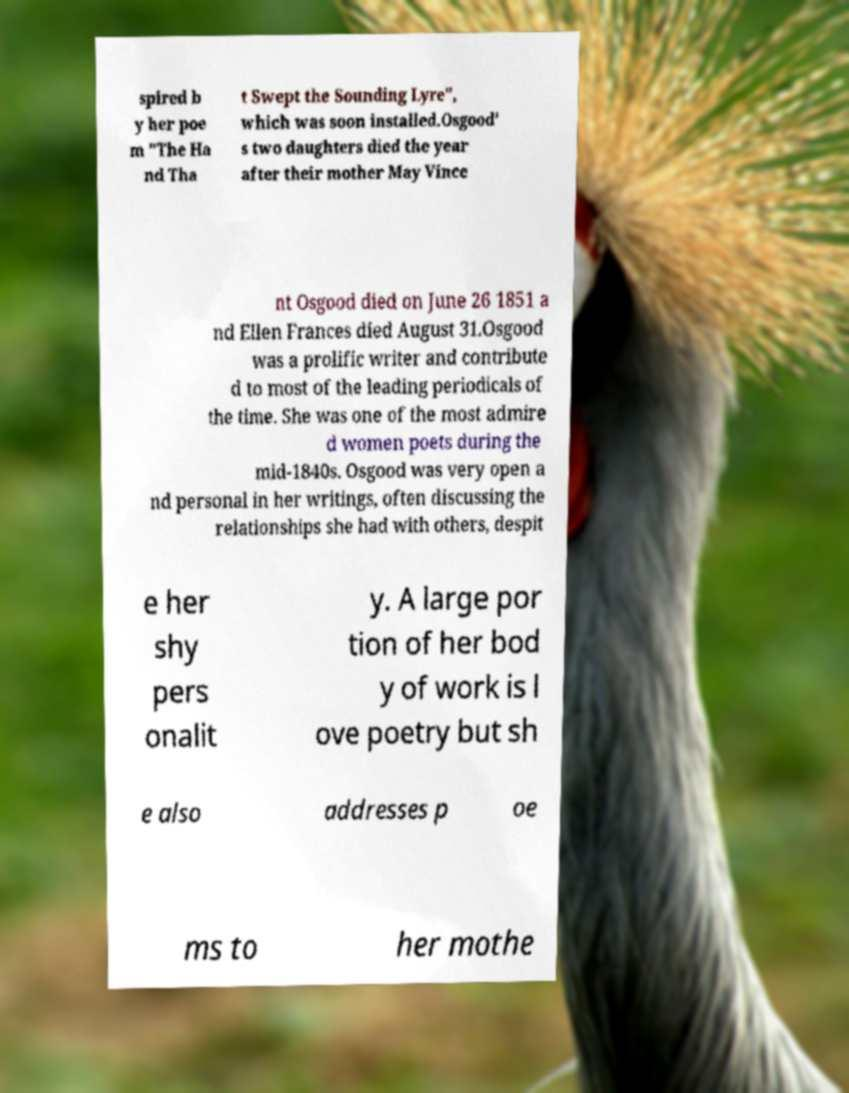For documentation purposes, I need the text within this image transcribed. Could you provide that? spired b y her poe m "The Ha nd Tha t Swept the Sounding Lyre", which was soon installed.Osgood' s two daughters died the year after their mother May Vince nt Osgood died on June 26 1851 a nd Ellen Frances died August 31.Osgood was a prolific writer and contribute d to most of the leading periodicals of the time. She was one of the most admire d women poets during the mid-1840s. Osgood was very open a nd personal in her writings, often discussing the relationships she had with others, despit e her shy pers onalit y. A large por tion of her bod y of work is l ove poetry but sh e also addresses p oe ms to her mothe 